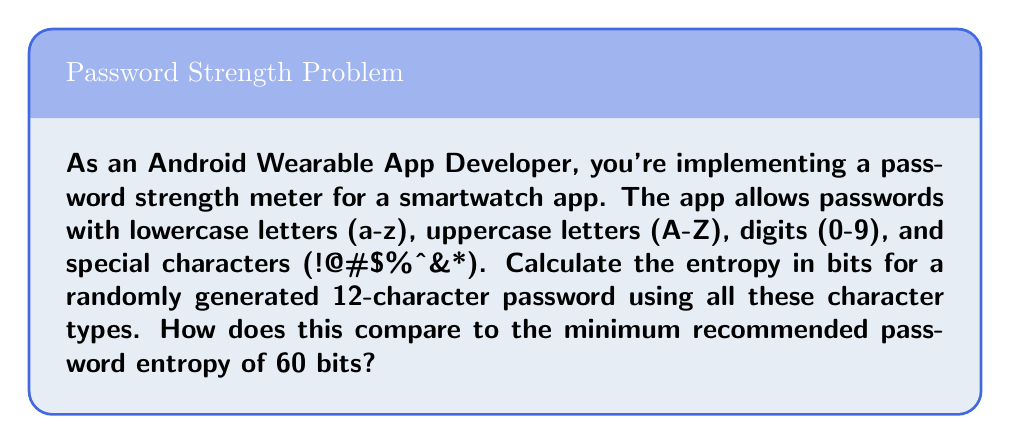Solve this math problem. To calculate the entropy of a password, we use the formula:

$$H = L \log_2(N)$$

Where:
$H$ = entropy in bits
$L$ = password length
$N$ = size of the character set

Step 1: Determine the size of the character set (N)
- Lowercase letters: 26
- Uppercase letters: 26
- Digits: 10
- Special characters: 8
Total: $N = 26 + 26 + 10 + 8 = 70$

Step 2: Apply the formula with L = 12 and N = 70
$$H = 12 \log_2(70)$$

Step 3: Calculate the result
$$H = 12 \times 6.129283016944966$$
$$H \approx 73.55139620333959 \text{ bits}$$

Step 4: Compare to the minimum recommended entropy
73.55 bits > 60 bits, so this password exceeds the minimum recommendation.

The entropy is about 22.6% higher than the minimum (73.55 / 60 ≈ 1.226).
Answer: 73.55 bits, exceeding the 60-bit minimum by 22.6% 